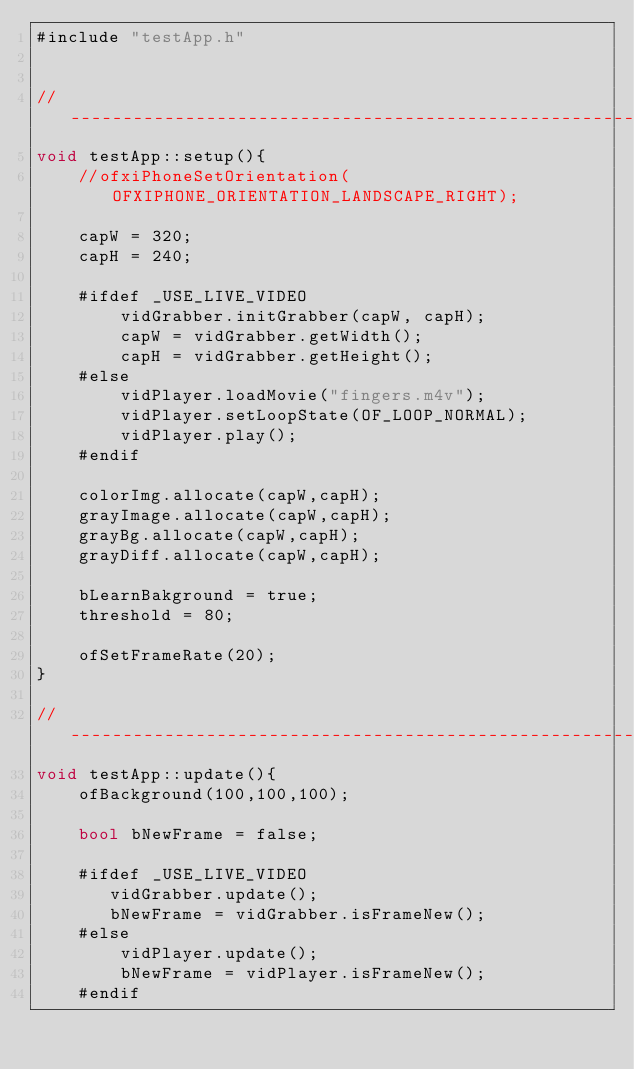Convert code to text. <code><loc_0><loc_0><loc_500><loc_500><_ObjectiveC_>#include "testApp.h"


//--------------------------------------------------------------
void testApp::setup(){	
	//ofxiPhoneSetOrientation(OFXIPHONE_ORIENTATION_LANDSCAPE_RIGHT);

	capW = 320;
	capH = 240;

	#ifdef _USE_LIVE_VIDEO
		vidGrabber.initGrabber(capW, capH);
		capW = vidGrabber.getWidth();
		capH = vidGrabber.getHeight();
    #else	
        vidPlayer.loadMovie("fingers.m4v");
        vidPlayer.setLoopState(OF_LOOP_NORMAL);
		vidPlayer.play();
	#endif

    colorImg.allocate(capW,capH);
    grayImage.allocate(capW,capH);
    grayBg.allocate(capW,capH);
    grayDiff.allocate(capW,capH);	

	bLearnBakground = true;
	threshold = 80;
	
	ofSetFrameRate(20);
}

//--------------------------------------------------------------
void testApp::update(){
	ofBackground(100,100,100);

    bool bNewFrame = false;

	#ifdef _USE_LIVE_VIDEO
       vidGrabber.update();
	   bNewFrame = vidGrabber.isFrameNew();
    #else
        vidPlayer.update();
        bNewFrame = vidPlayer.isFrameNew();    
    #endif


    </code> 